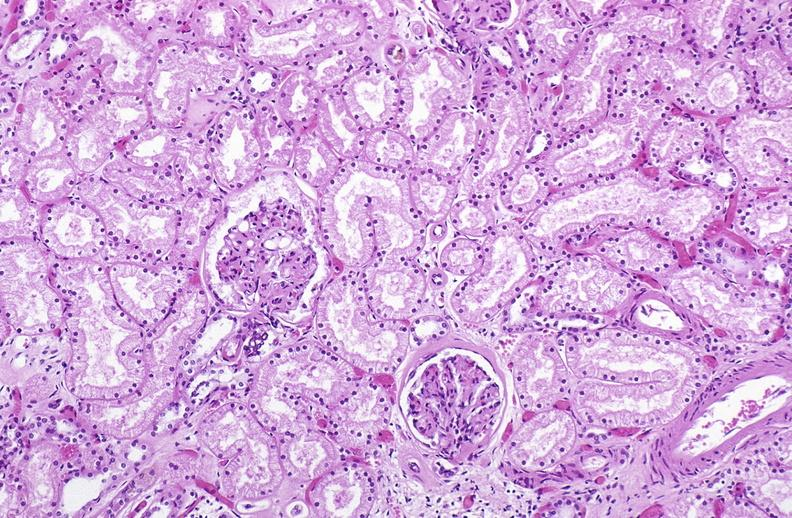what is present?
Answer the question using a single word or phrase. Urinary 